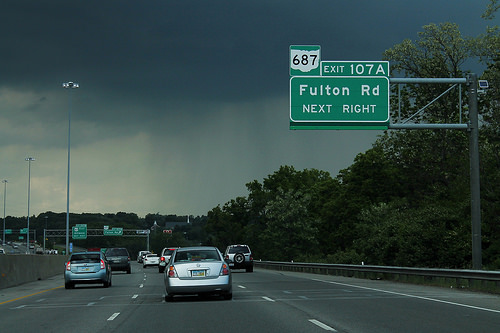<image>
Is the car under the street sign? Yes. The car is positioned underneath the street sign, with the street sign above it in the vertical space. Where is the car in relation to the light pole? Is it next to the light pole? No. The car is not positioned next to the light pole. They are located in different areas of the scene. 